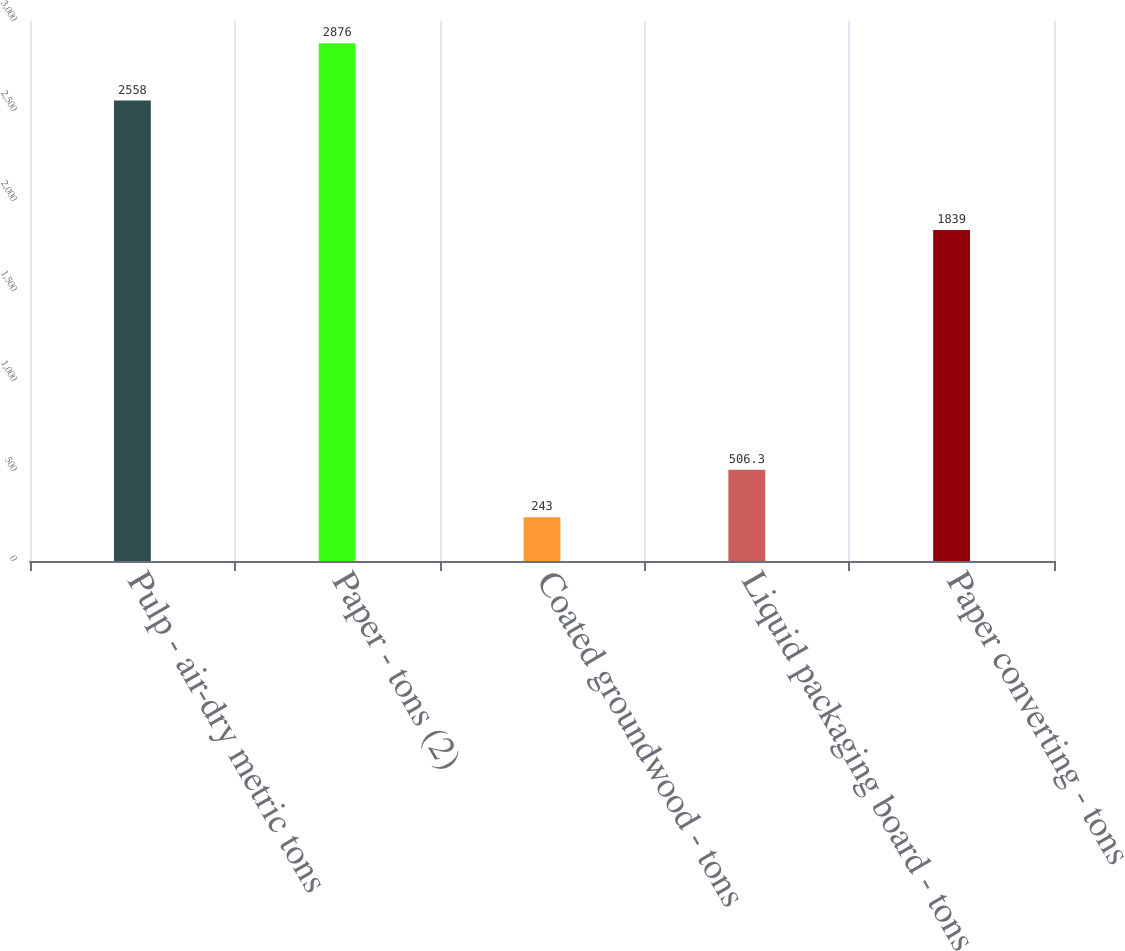<chart> <loc_0><loc_0><loc_500><loc_500><bar_chart><fcel>Pulp - air-dry metric tons<fcel>Paper - tons (2)<fcel>Coated groundwood - tons<fcel>Liquid packaging board - tons<fcel>Paper converting - tons<nl><fcel>2558<fcel>2876<fcel>243<fcel>506.3<fcel>1839<nl></chart> 